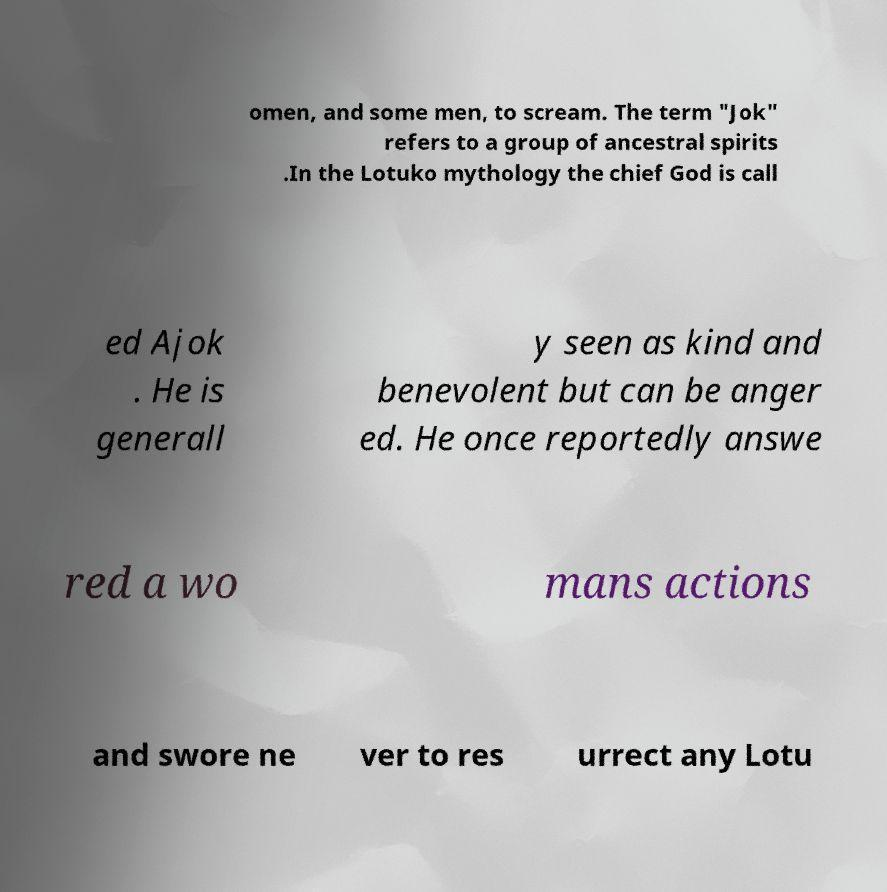I need the written content from this picture converted into text. Can you do that? omen, and some men, to scream. The term "Jok" refers to a group of ancestral spirits .In the Lotuko mythology the chief God is call ed Ajok . He is generall y seen as kind and benevolent but can be anger ed. He once reportedly answe red a wo mans actions and swore ne ver to res urrect any Lotu 